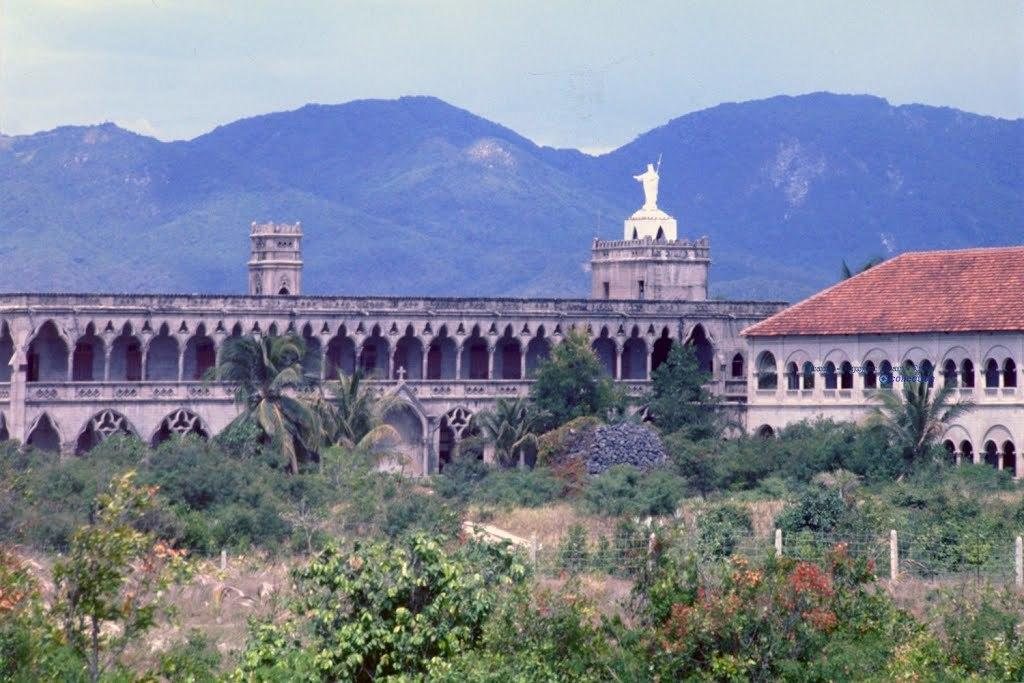What type of natural elements can be seen in the image? There are trees in the image. What man-made structures are present in the image? There is a fence, buildings, and a statue in the image. What geographical feature is visible in the image? There are mountains in the image. What is visible in the background of the image? The sky is visible in the background of the image. How many feet are visible on the statue in the image? There is no statue with feet visible in the image; the statue is not described in detail. Can you see an airplane flying in the sky in the image? There is no airplane visible in the sky in the image. Are there any robins perched on the trees in the image? There is no mention of robins or any other birds in the image; only trees are mentioned. 